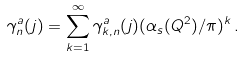<formula> <loc_0><loc_0><loc_500><loc_500>\gamma _ { n } ^ { a } ( j ) = \sum _ { k = 1 } ^ { \infty } \gamma _ { k , n } ^ { a } ( j ) ( \alpha _ { s } ( Q ^ { 2 } ) / \pi ) ^ { k } \, .</formula> 